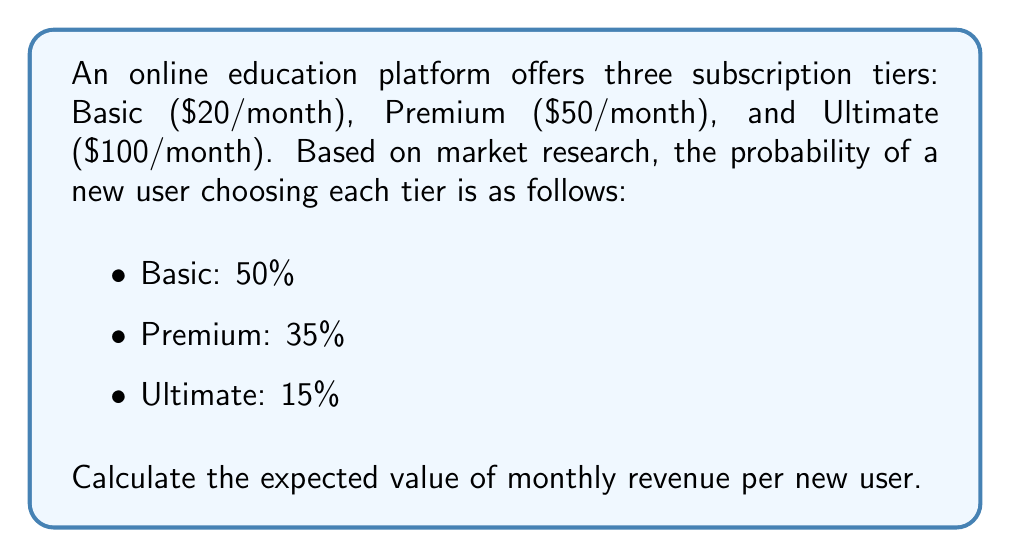What is the answer to this math problem? To calculate the expected value of monthly revenue per new user, we need to follow these steps:

1. Identify the random variable:
   Let X be the monthly revenue from a new user.

2. List the possible values of X and their probabilities:
   $$X = \begin{cases}
   20 & \text{with probability } 0.50 \\
   50 & \text{with probability } 0.35 \\
   100 & \text{with probability } 0.15
   \end{cases}$$

3. Calculate the expected value using the formula:
   $$E(X) = \sum_{i=1}^{n} x_i \cdot p(x_i)$$
   Where $x_i$ are the possible values of X and $p(x_i)$ are their respective probabilities.

4. Substitute the values:
   $$E(X) = 20 \cdot 0.50 + 50 \cdot 0.35 + 100 \cdot 0.15$$

5. Perform the calculations:
   $$E(X) = 10 + 17.50 + 15 = 42.50$$

Therefore, the expected value of monthly revenue per new user is $42.50.
Answer: $42.50 